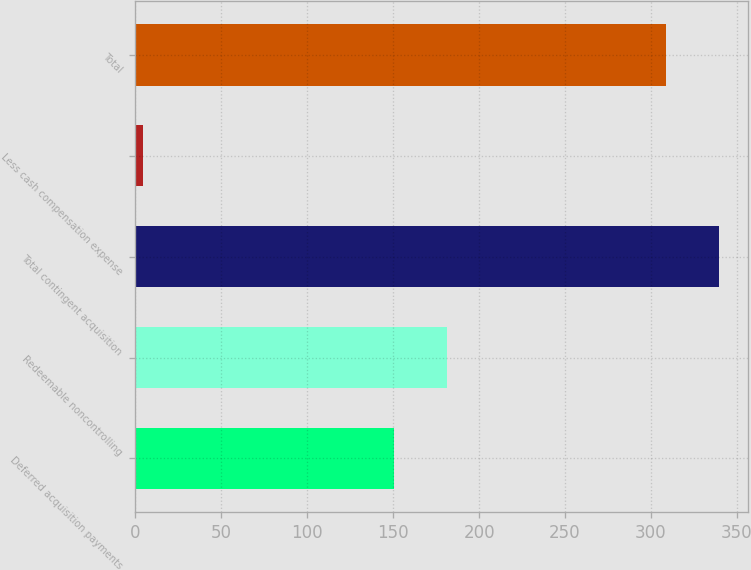Convert chart to OTSL. <chart><loc_0><loc_0><loc_500><loc_500><bar_chart><fcel>Deferred acquisition payments<fcel>Redeemable noncontrolling<fcel>Total contingent acquisition<fcel>Less cash compensation expense<fcel>Total<nl><fcel>150.3<fcel>181.18<fcel>339.68<fcel>4.2<fcel>308.8<nl></chart> 